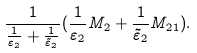Convert formula to latex. <formula><loc_0><loc_0><loc_500><loc_500>\frac { 1 } { \frac { 1 } { \varepsilon _ { 2 } } + \frac { 1 } { \tilde { \varepsilon } _ { 2 } } } ( \frac { 1 } { \varepsilon _ { 2 } } M _ { 2 } + \frac { 1 } { \tilde { \varepsilon } _ { 2 } } M _ { 2 1 } ) .</formula> 